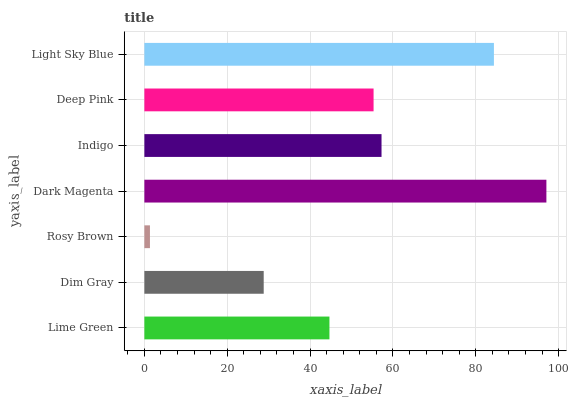Is Rosy Brown the minimum?
Answer yes or no. Yes. Is Dark Magenta the maximum?
Answer yes or no. Yes. Is Dim Gray the minimum?
Answer yes or no. No. Is Dim Gray the maximum?
Answer yes or no. No. Is Lime Green greater than Dim Gray?
Answer yes or no. Yes. Is Dim Gray less than Lime Green?
Answer yes or no. Yes. Is Dim Gray greater than Lime Green?
Answer yes or no. No. Is Lime Green less than Dim Gray?
Answer yes or no. No. Is Deep Pink the high median?
Answer yes or no. Yes. Is Deep Pink the low median?
Answer yes or no. Yes. Is Lime Green the high median?
Answer yes or no. No. Is Lime Green the low median?
Answer yes or no. No. 